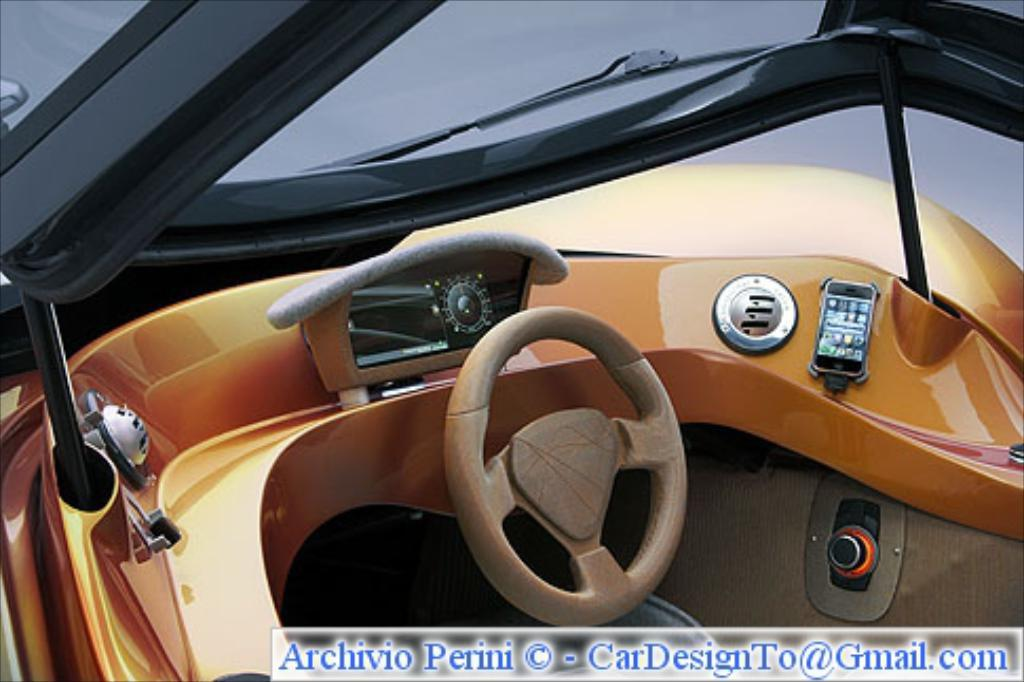What is the main object in the center of the image? There is a steering wheel in the middle of the image. Where is the text located in the image? The text is written at the bottom of the image. What type of bucket is being used for the feast in the image? There is no bucket or feast present in the image; it only features a steering wheel and text. 